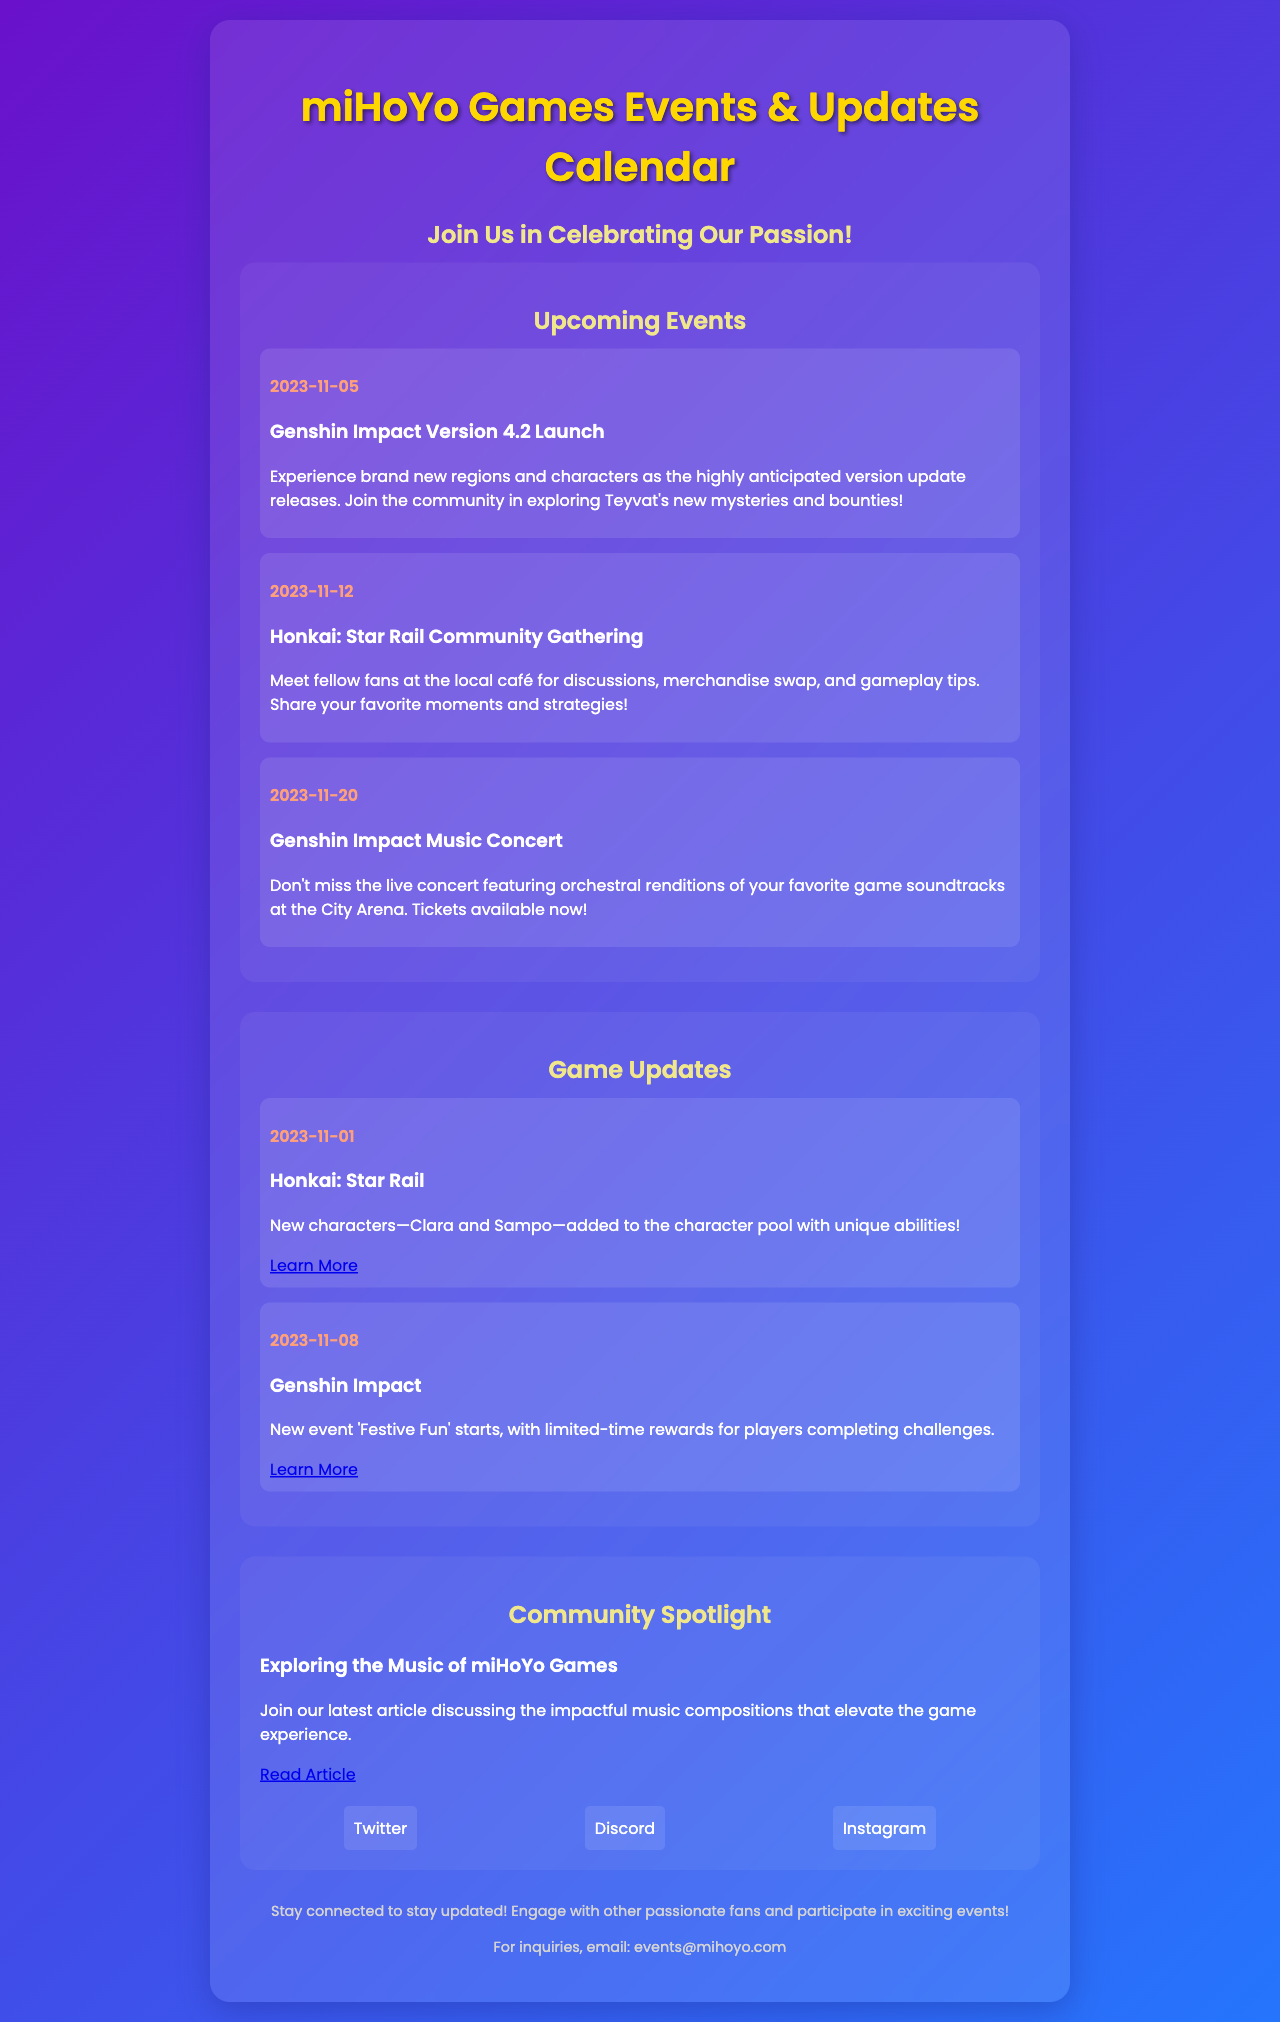What is the title of the brochure? The title is prominently featured at the top of the document, showcasing the main theme.
Answer: miHoYo Games Events & Updates Calendar When is the Genshin Impact Version 4.2 Launch scheduled? The date is provided in the upcoming events section of the brochure.
Answer: 2023-11-05 Which game has a community gathering on November 12, 2023? The event section lists the game associated with the gathering along with the date.
Answer: Honkai: Star Rail What is the date for the Genshin Impact Music Concert? The specific date is mentioned in the events section related to this concert.
Answer: 2023-11-20 What new characters were introduced in Honkai: Star Rail? The updates section highlights the main content change, including new characters.
Answer: Clara and Sampo What new event is starting on November 8, 2023, in Genshin Impact? The updates section contains the title of the new event along with the date.
Answer: Festive Fun What article topic is featured in the Community Spotlight? The community spotlight section describes the subject of the article featured there.
Answer: Exploring the Music of miHoYo Games How can fans stay connected with miHoYo updates? The social links section encourages engagement through specific platforms.
Answer: Twitter, Discord, Instagram What is the purpose of the brochure? This information is clear in the introduction, highlighting the intention behind the document.
Answer: Celebrating Our Passion 